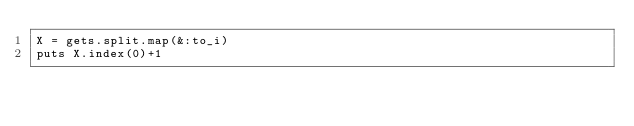Convert code to text. <code><loc_0><loc_0><loc_500><loc_500><_Ruby_>X = gets.split.map(&:to_i)
puts X.index(0)+1</code> 